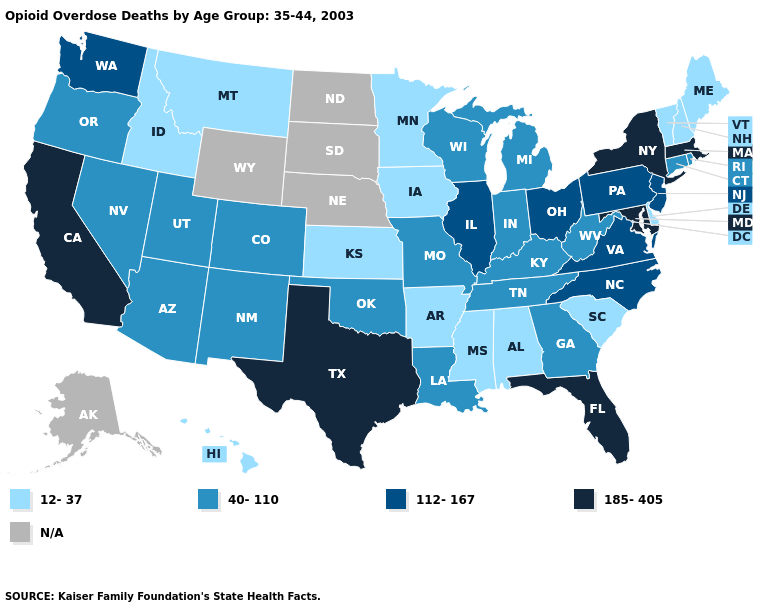Which states have the lowest value in the USA?
Write a very short answer. Alabama, Arkansas, Delaware, Hawaii, Idaho, Iowa, Kansas, Maine, Minnesota, Mississippi, Montana, New Hampshire, South Carolina, Vermont. Which states hav the highest value in the Northeast?
Be succinct. Massachusetts, New York. Which states have the highest value in the USA?
Concise answer only. California, Florida, Maryland, Massachusetts, New York, Texas. What is the lowest value in the USA?
Answer briefly. 12-37. What is the lowest value in states that border North Dakota?
Concise answer only. 12-37. What is the value of New Jersey?
Give a very brief answer. 112-167. Name the states that have a value in the range 185-405?
Short answer required. California, Florida, Maryland, Massachusetts, New York, Texas. Name the states that have a value in the range N/A?
Give a very brief answer. Alaska, Nebraska, North Dakota, South Dakota, Wyoming. Which states hav the highest value in the MidWest?
Quick response, please. Illinois, Ohio. Which states have the lowest value in the USA?
Answer briefly. Alabama, Arkansas, Delaware, Hawaii, Idaho, Iowa, Kansas, Maine, Minnesota, Mississippi, Montana, New Hampshire, South Carolina, Vermont. Name the states that have a value in the range N/A?
Write a very short answer. Alaska, Nebraska, North Dakota, South Dakota, Wyoming. Does Vermont have the lowest value in the Northeast?
Write a very short answer. Yes. Among the states that border Iowa , which have the lowest value?
Concise answer only. Minnesota. Name the states that have a value in the range 40-110?
Write a very short answer. Arizona, Colorado, Connecticut, Georgia, Indiana, Kentucky, Louisiana, Michigan, Missouri, Nevada, New Mexico, Oklahoma, Oregon, Rhode Island, Tennessee, Utah, West Virginia, Wisconsin. 